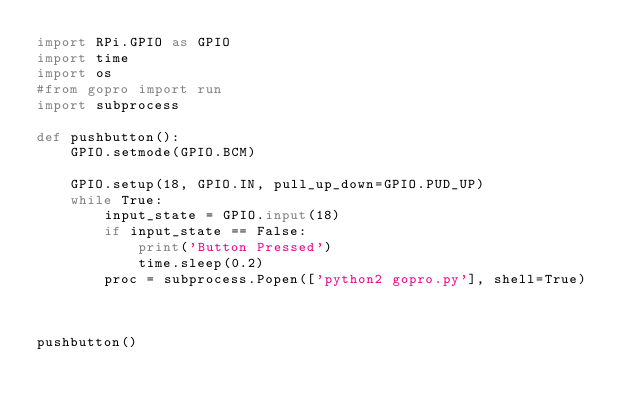Convert code to text. <code><loc_0><loc_0><loc_500><loc_500><_Python_>import RPi.GPIO as GPIO
import time
import os
#from gopro import run
import subprocess

def pushbutton():
	GPIO.setmode(GPIO.BCM)
	
	GPIO.setup(18, GPIO.IN, pull_up_down=GPIO.PUD_UP)
	while True:
	    input_state = GPIO.input(18)
	    if input_state == False:
	        print('Button Pressed')
        	time.sleep(0.2)
		proc = subprocess.Popen(['python2 gopro.py'], shell=True)
		

			
pushbutton()
</code> 